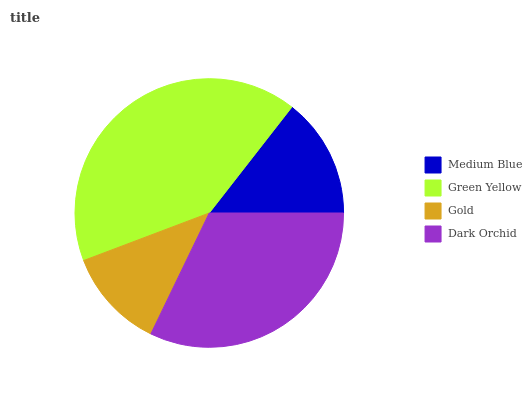Is Gold the minimum?
Answer yes or no. Yes. Is Green Yellow the maximum?
Answer yes or no. Yes. Is Green Yellow the minimum?
Answer yes or no. No. Is Gold the maximum?
Answer yes or no. No. Is Green Yellow greater than Gold?
Answer yes or no. Yes. Is Gold less than Green Yellow?
Answer yes or no. Yes. Is Gold greater than Green Yellow?
Answer yes or no. No. Is Green Yellow less than Gold?
Answer yes or no. No. Is Dark Orchid the high median?
Answer yes or no. Yes. Is Medium Blue the low median?
Answer yes or no. Yes. Is Medium Blue the high median?
Answer yes or no. No. Is Dark Orchid the low median?
Answer yes or no. No. 